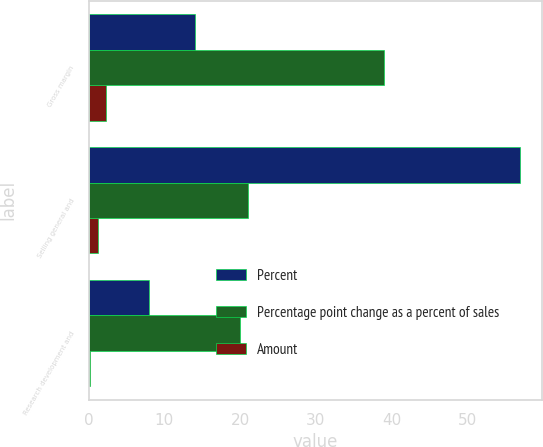Convert chart. <chart><loc_0><loc_0><loc_500><loc_500><stacked_bar_chart><ecel><fcel>Gross margin<fcel>Selling general and<fcel>Research development and<nl><fcel>Percent<fcel>14<fcel>57<fcel>8<nl><fcel>Percentage point change as a percent of sales<fcel>39<fcel>21<fcel>20<nl><fcel>Amount<fcel>2.3<fcel>1.2<fcel>0.2<nl></chart> 